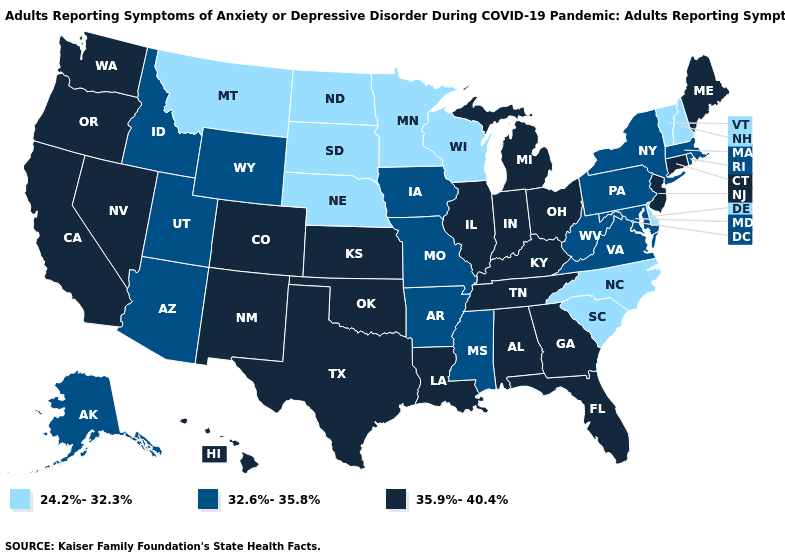Does Arizona have the highest value in the USA?
Concise answer only. No. What is the highest value in the USA?
Quick response, please. 35.9%-40.4%. Which states hav the highest value in the South?
Quick response, please. Alabama, Florida, Georgia, Kentucky, Louisiana, Oklahoma, Tennessee, Texas. What is the value of Tennessee?
Write a very short answer. 35.9%-40.4%. Does Kentucky have the same value as Rhode Island?
Quick response, please. No. Name the states that have a value in the range 24.2%-32.3%?
Keep it brief. Delaware, Minnesota, Montana, Nebraska, New Hampshire, North Carolina, North Dakota, South Carolina, South Dakota, Vermont, Wisconsin. Does Hawaii have the highest value in the USA?
Keep it brief. Yes. Among the states that border Nevada , which have the highest value?
Give a very brief answer. California, Oregon. Name the states that have a value in the range 35.9%-40.4%?
Quick response, please. Alabama, California, Colorado, Connecticut, Florida, Georgia, Hawaii, Illinois, Indiana, Kansas, Kentucky, Louisiana, Maine, Michigan, Nevada, New Jersey, New Mexico, Ohio, Oklahoma, Oregon, Tennessee, Texas, Washington. Name the states that have a value in the range 24.2%-32.3%?
Give a very brief answer. Delaware, Minnesota, Montana, Nebraska, New Hampshire, North Carolina, North Dakota, South Carolina, South Dakota, Vermont, Wisconsin. Which states have the lowest value in the USA?
Short answer required. Delaware, Minnesota, Montana, Nebraska, New Hampshire, North Carolina, North Dakota, South Carolina, South Dakota, Vermont, Wisconsin. What is the value of Hawaii?
Be succinct. 35.9%-40.4%. What is the value of New York?
Write a very short answer. 32.6%-35.8%. Name the states that have a value in the range 35.9%-40.4%?
Keep it brief. Alabama, California, Colorado, Connecticut, Florida, Georgia, Hawaii, Illinois, Indiana, Kansas, Kentucky, Louisiana, Maine, Michigan, Nevada, New Jersey, New Mexico, Ohio, Oklahoma, Oregon, Tennessee, Texas, Washington. 